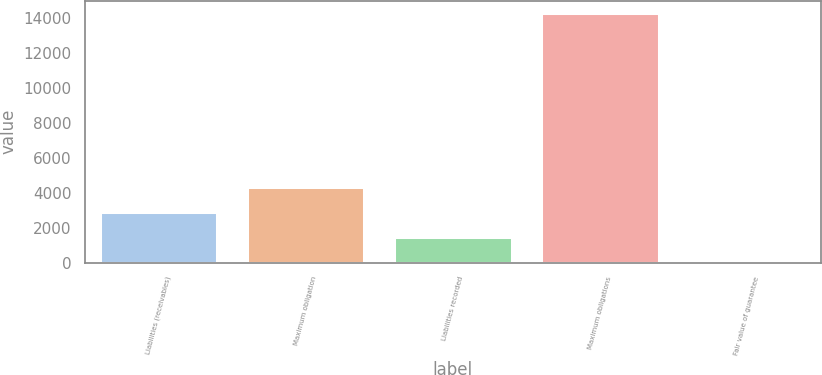<chart> <loc_0><loc_0><loc_500><loc_500><bar_chart><fcel>Liabilities (receivables)<fcel>Maximum obligation<fcel>Liabilities recorded<fcel>Maximum obligations<fcel>Fair value of guarantee<nl><fcel>2886.6<fcel>4306.9<fcel>1466.3<fcel>14249<fcel>46<nl></chart> 